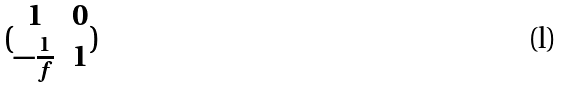<formula> <loc_0><loc_0><loc_500><loc_500>( \begin{matrix} 1 & 0 \\ - \frac { 1 } { f } & 1 \end{matrix} )</formula> 